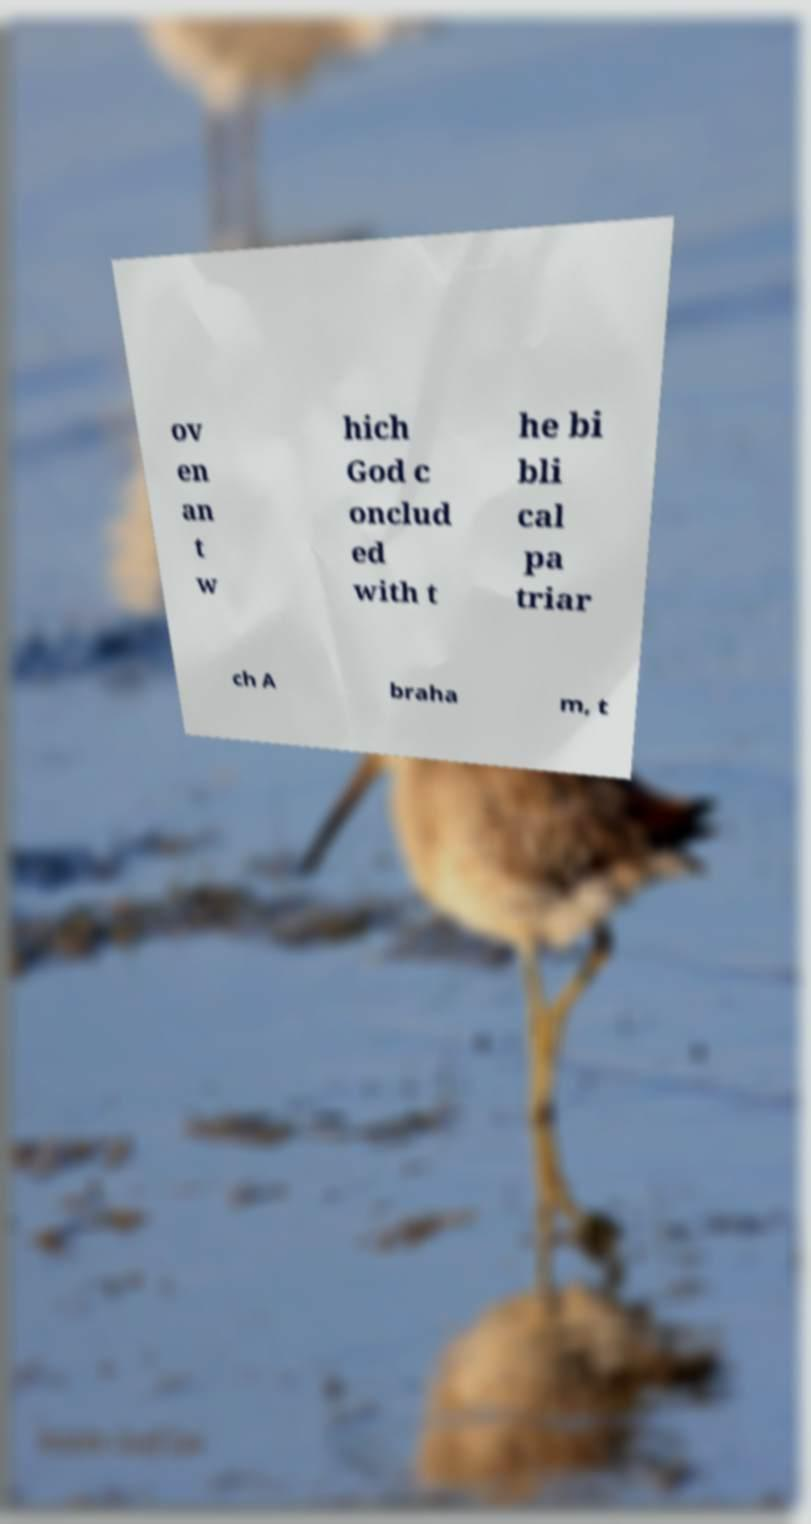Please read and relay the text visible in this image. What does it say? ov en an t w hich God c onclud ed with t he bi bli cal pa triar ch A braha m, t 